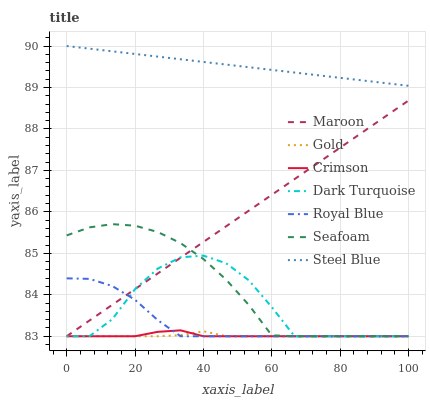Does Gold have the minimum area under the curve?
Answer yes or no. Yes. Does Steel Blue have the maximum area under the curve?
Answer yes or no. Yes. Does Dark Turquoise have the minimum area under the curve?
Answer yes or no. No. Does Dark Turquoise have the maximum area under the curve?
Answer yes or no. No. Is Steel Blue the smoothest?
Answer yes or no. Yes. Is Dark Turquoise the roughest?
Answer yes or no. Yes. Is Seafoam the smoothest?
Answer yes or no. No. Is Seafoam the roughest?
Answer yes or no. No. Does Steel Blue have the lowest value?
Answer yes or no. No. Does Steel Blue have the highest value?
Answer yes or no. Yes. Does Dark Turquoise have the highest value?
Answer yes or no. No. Is Maroon less than Steel Blue?
Answer yes or no. Yes. Is Steel Blue greater than Dark Turquoise?
Answer yes or no. Yes. Does Dark Turquoise intersect Maroon?
Answer yes or no. Yes. Is Dark Turquoise less than Maroon?
Answer yes or no. No. Is Dark Turquoise greater than Maroon?
Answer yes or no. No. Does Maroon intersect Steel Blue?
Answer yes or no. No. 